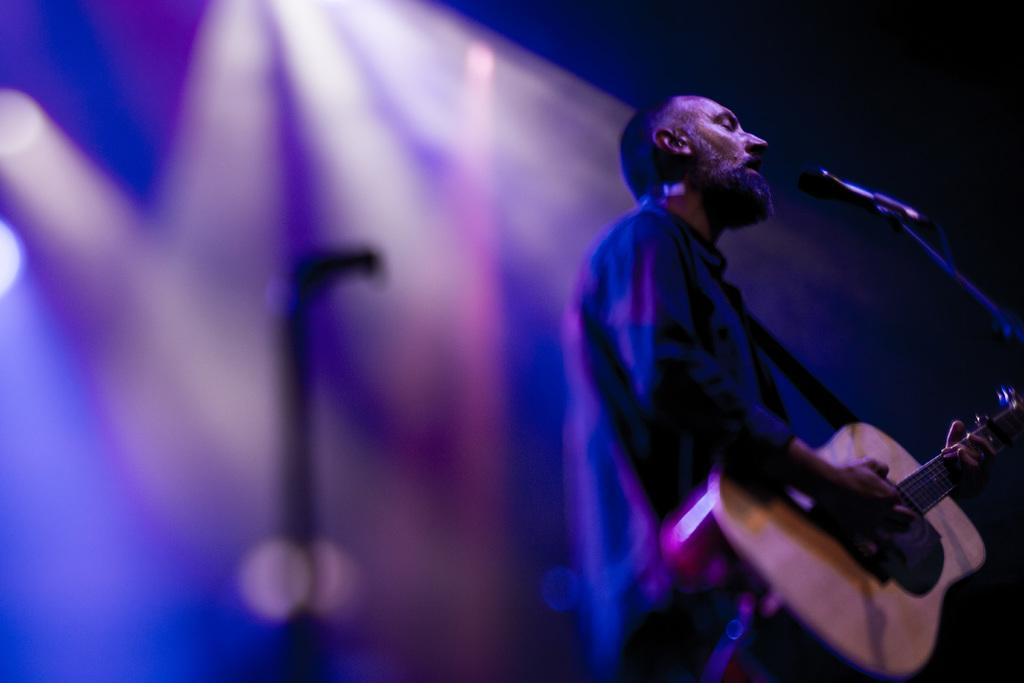Who is present in the image? There is a man in the image. What is the man doing in the image? The man is standing in the image. What object is the man holding in his hand? The man is holding a guitar in his hand. What is in front of the man? There is a microphone in front of the man. What type of health issues is the man experiencing in the image? There is no indication of any health issues in the image; the man is standing and holding a guitar. Can you tell me how many horses are present in the image? There are no horses present in the image; it features a man holding a guitar and standing in front of a microphone. 